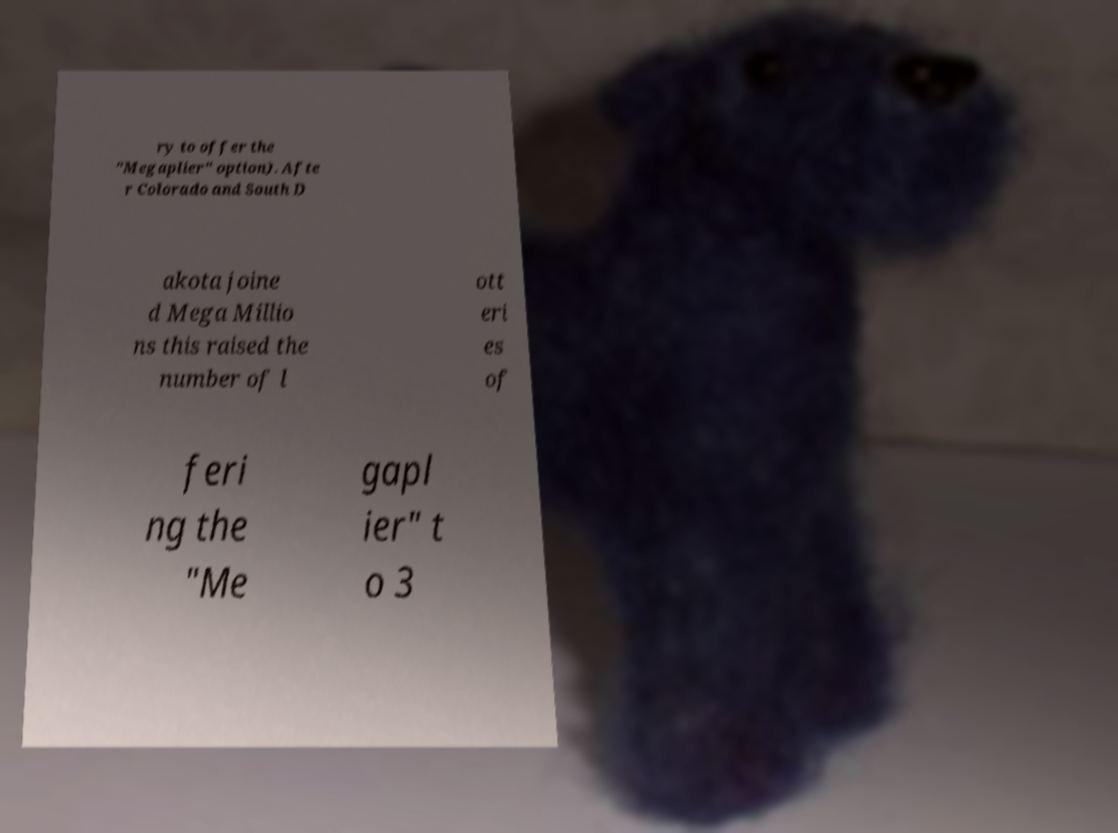There's text embedded in this image that I need extracted. Can you transcribe it verbatim? ry to offer the "Megaplier" option). Afte r Colorado and South D akota joine d Mega Millio ns this raised the number of l ott eri es of feri ng the "Me gapl ier" t o 3 